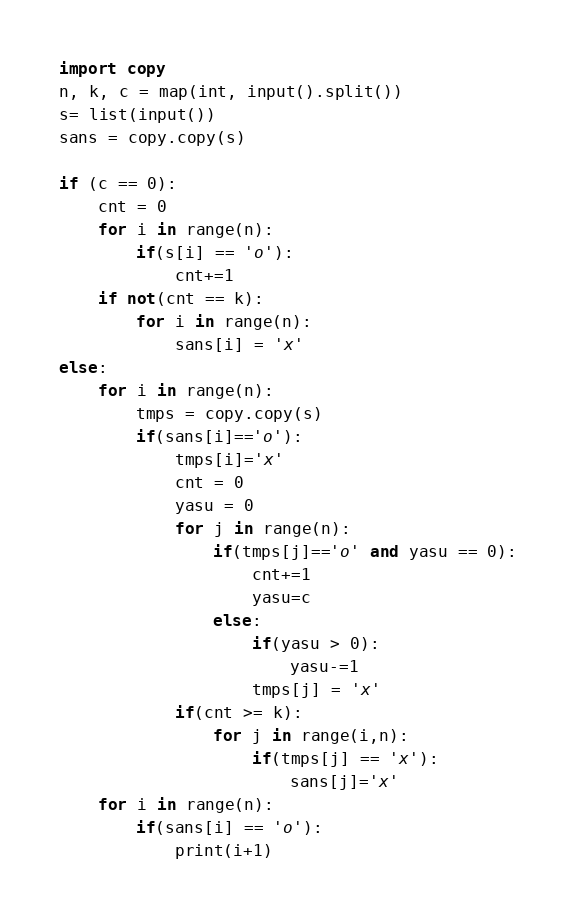Convert code to text. <code><loc_0><loc_0><loc_500><loc_500><_Python_>import copy
n, k, c = map(int, input().split())
s= list(input())
sans = copy.copy(s)

if (c == 0):
    cnt = 0
    for i in range(n):
        if(s[i] == 'o'):
            cnt+=1
    if not(cnt == k):
        for i in range(n):
            sans[i] = 'x'
else:
    for i in range(n):
        tmps = copy.copy(s)
        if(sans[i]=='o'):
            tmps[i]='x'
            cnt = 0
            yasu = 0
            for j in range(n):
                if(tmps[j]=='o' and yasu == 0):
                    cnt+=1
                    yasu=c
                else:
                    if(yasu > 0):
                        yasu-=1
                    tmps[j] = 'x'
            if(cnt >= k):
                for j in range(i,n):
                    if(tmps[j] == 'x'):
                        sans[j]='x'
    for i in range(n):
        if(sans[i] == 'o'):
            print(i+1)</code> 